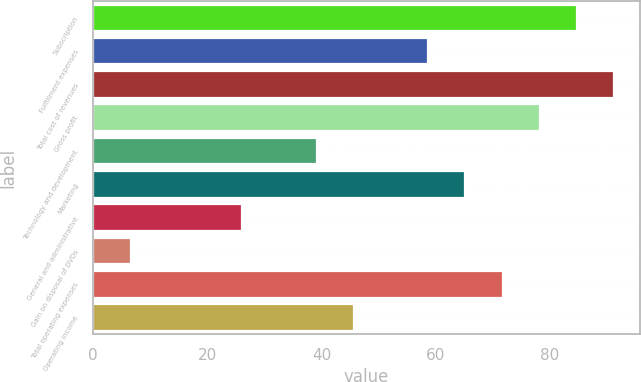Convert chart. <chart><loc_0><loc_0><loc_500><loc_500><bar_chart><fcel>Subscription<fcel>Fulfillment expenses<fcel>Total cost of revenues<fcel>Gross profit<fcel>Technology and development<fcel>Marketing<fcel>General and administrative<fcel>Gain on disposal of DVDs<fcel>Total operating expenses<fcel>Operating income<nl><fcel>84.73<fcel>58.69<fcel>91.24<fcel>78.22<fcel>39.16<fcel>65.2<fcel>26.14<fcel>6.61<fcel>71.71<fcel>45.67<nl></chart> 